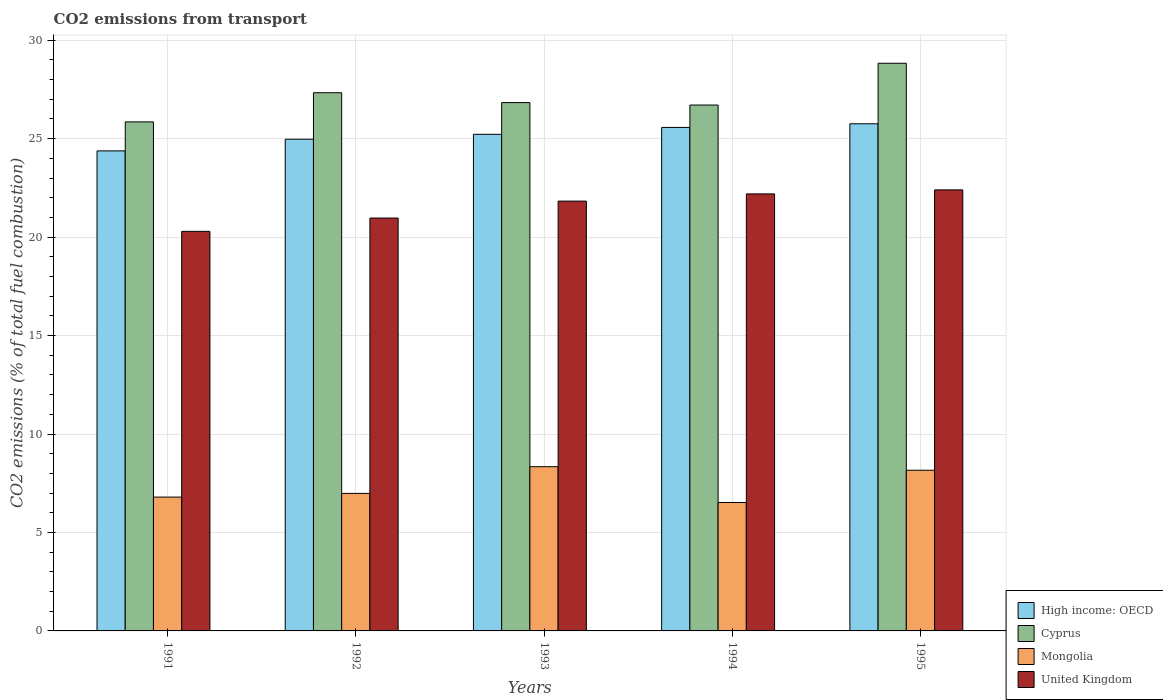How many different coloured bars are there?
Make the answer very short. 4. Are the number of bars per tick equal to the number of legend labels?
Give a very brief answer. Yes. Are the number of bars on each tick of the X-axis equal?
Provide a succinct answer. Yes. How many bars are there on the 4th tick from the right?
Make the answer very short. 4. What is the label of the 3rd group of bars from the left?
Ensure brevity in your answer.  1993. What is the total CO2 emitted in Mongolia in 1991?
Your answer should be compact. 6.8. Across all years, what is the maximum total CO2 emitted in Cyprus?
Offer a very short reply. 28.83. Across all years, what is the minimum total CO2 emitted in High income: OECD?
Ensure brevity in your answer.  24.38. In which year was the total CO2 emitted in High income: OECD minimum?
Your answer should be compact. 1991. What is the total total CO2 emitted in High income: OECD in the graph?
Your answer should be compact. 125.89. What is the difference between the total CO2 emitted in United Kingdom in 1991 and that in 1994?
Provide a short and direct response. -1.9. What is the difference between the total CO2 emitted in Cyprus in 1991 and the total CO2 emitted in Mongolia in 1995?
Offer a very short reply. 17.69. What is the average total CO2 emitted in United Kingdom per year?
Offer a very short reply. 21.53. In the year 1995, what is the difference between the total CO2 emitted in Cyprus and total CO2 emitted in United Kingdom?
Provide a short and direct response. 6.43. What is the ratio of the total CO2 emitted in Mongolia in 1993 to that in 1994?
Give a very brief answer. 1.28. Is the total CO2 emitted in Mongolia in 1991 less than that in 1993?
Give a very brief answer. Yes. Is the difference between the total CO2 emitted in Cyprus in 1991 and 1992 greater than the difference between the total CO2 emitted in United Kingdom in 1991 and 1992?
Offer a terse response. No. What is the difference between the highest and the second highest total CO2 emitted in Mongolia?
Offer a very short reply. 0.18. What is the difference between the highest and the lowest total CO2 emitted in Mongolia?
Offer a very short reply. 1.82. In how many years, is the total CO2 emitted in Cyprus greater than the average total CO2 emitted in Cyprus taken over all years?
Keep it short and to the point. 2. Is the sum of the total CO2 emitted in Mongolia in 1993 and 1995 greater than the maximum total CO2 emitted in High income: OECD across all years?
Offer a very short reply. No. What does the 3rd bar from the left in 1995 represents?
Give a very brief answer. Mongolia. What does the 2nd bar from the right in 1991 represents?
Offer a very short reply. Mongolia. Is it the case that in every year, the sum of the total CO2 emitted in United Kingdom and total CO2 emitted in High income: OECD is greater than the total CO2 emitted in Mongolia?
Offer a terse response. Yes. Does the graph contain any zero values?
Provide a short and direct response. No. How many legend labels are there?
Give a very brief answer. 4. What is the title of the graph?
Ensure brevity in your answer.  CO2 emissions from transport. What is the label or title of the Y-axis?
Provide a short and direct response. CO2 emissions (% of total fuel combustion). What is the CO2 emissions (% of total fuel combustion) in High income: OECD in 1991?
Offer a terse response. 24.38. What is the CO2 emissions (% of total fuel combustion) in Cyprus in 1991?
Your answer should be very brief. 25.85. What is the CO2 emissions (% of total fuel combustion) of Mongolia in 1991?
Your answer should be very brief. 6.8. What is the CO2 emissions (% of total fuel combustion) of United Kingdom in 1991?
Keep it short and to the point. 20.29. What is the CO2 emissions (% of total fuel combustion) in High income: OECD in 1992?
Give a very brief answer. 24.97. What is the CO2 emissions (% of total fuel combustion) of Cyprus in 1992?
Ensure brevity in your answer.  27.33. What is the CO2 emissions (% of total fuel combustion) of Mongolia in 1992?
Your answer should be very brief. 6.98. What is the CO2 emissions (% of total fuel combustion) in United Kingdom in 1992?
Keep it short and to the point. 20.97. What is the CO2 emissions (% of total fuel combustion) in High income: OECD in 1993?
Offer a terse response. 25.22. What is the CO2 emissions (% of total fuel combustion) of Cyprus in 1993?
Your answer should be compact. 26.83. What is the CO2 emissions (% of total fuel combustion) of Mongolia in 1993?
Provide a short and direct response. 8.34. What is the CO2 emissions (% of total fuel combustion) in United Kingdom in 1993?
Offer a terse response. 21.83. What is the CO2 emissions (% of total fuel combustion) of High income: OECD in 1994?
Make the answer very short. 25.57. What is the CO2 emissions (% of total fuel combustion) in Cyprus in 1994?
Provide a succinct answer. 26.71. What is the CO2 emissions (% of total fuel combustion) in Mongolia in 1994?
Give a very brief answer. 6.52. What is the CO2 emissions (% of total fuel combustion) in United Kingdom in 1994?
Give a very brief answer. 22.19. What is the CO2 emissions (% of total fuel combustion) in High income: OECD in 1995?
Keep it short and to the point. 25.75. What is the CO2 emissions (% of total fuel combustion) in Cyprus in 1995?
Your response must be concise. 28.83. What is the CO2 emissions (% of total fuel combustion) of Mongolia in 1995?
Keep it short and to the point. 8.16. What is the CO2 emissions (% of total fuel combustion) of United Kingdom in 1995?
Your response must be concise. 22.4. Across all years, what is the maximum CO2 emissions (% of total fuel combustion) of High income: OECD?
Offer a terse response. 25.75. Across all years, what is the maximum CO2 emissions (% of total fuel combustion) in Cyprus?
Your answer should be compact. 28.83. Across all years, what is the maximum CO2 emissions (% of total fuel combustion) in Mongolia?
Keep it short and to the point. 8.34. Across all years, what is the maximum CO2 emissions (% of total fuel combustion) of United Kingdom?
Keep it short and to the point. 22.4. Across all years, what is the minimum CO2 emissions (% of total fuel combustion) of High income: OECD?
Keep it short and to the point. 24.38. Across all years, what is the minimum CO2 emissions (% of total fuel combustion) in Cyprus?
Your response must be concise. 25.85. Across all years, what is the minimum CO2 emissions (% of total fuel combustion) in Mongolia?
Provide a succinct answer. 6.52. Across all years, what is the minimum CO2 emissions (% of total fuel combustion) of United Kingdom?
Your answer should be very brief. 20.29. What is the total CO2 emissions (% of total fuel combustion) of High income: OECD in the graph?
Make the answer very short. 125.89. What is the total CO2 emissions (% of total fuel combustion) of Cyprus in the graph?
Give a very brief answer. 135.54. What is the total CO2 emissions (% of total fuel combustion) in Mongolia in the graph?
Make the answer very short. 36.8. What is the total CO2 emissions (% of total fuel combustion) in United Kingdom in the graph?
Your answer should be very brief. 107.67. What is the difference between the CO2 emissions (% of total fuel combustion) in High income: OECD in 1991 and that in 1992?
Your answer should be compact. -0.59. What is the difference between the CO2 emissions (% of total fuel combustion) in Cyprus in 1991 and that in 1992?
Offer a terse response. -1.48. What is the difference between the CO2 emissions (% of total fuel combustion) of Mongolia in 1991 and that in 1992?
Offer a very short reply. -0.19. What is the difference between the CO2 emissions (% of total fuel combustion) in United Kingdom in 1991 and that in 1992?
Keep it short and to the point. -0.68. What is the difference between the CO2 emissions (% of total fuel combustion) in High income: OECD in 1991 and that in 1993?
Give a very brief answer. -0.84. What is the difference between the CO2 emissions (% of total fuel combustion) in Cyprus in 1991 and that in 1993?
Provide a short and direct response. -0.98. What is the difference between the CO2 emissions (% of total fuel combustion) in Mongolia in 1991 and that in 1993?
Give a very brief answer. -1.54. What is the difference between the CO2 emissions (% of total fuel combustion) in United Kingdom in 1991 and that in 1993?
Provide a succinct answer. -1.54. What is the difference between the CO2 emissions (% of total fuel combustion) in High income: OECD in 1991 and that in 1994?
Provide a succinct answer. -1.19. What is the difference between the CO2 emissions (% of total fuel combustion) in Cyprus in 1991 and that in 1994?
Keep it short and to the point. -0.86. What is the difference between the CO2 emissions (% of total fuel combustion) in Mongolia in 1991 and that in 1994?
Ensure brevity in your answer.  0.27. What is the difference between the CO2 emissions (% of total fuel combustion) of United Kingdom in 1991 and that in 1994?
Make the answer very short. -1.9. What is the difference between the CO2 emissions (% of total fuel combustion) of High income: OECD in 1991 and that in 1995?
Your answer should be very brief. -1.38. What is the difference between the CO2 emissions (% of total fuel combustion) of Cyprus in 1991 and that in 1995?
Keep it short and to the point. -2.98. What is the difference between the CO2 emissions (% of total fuel combustion) of Mongolia in 1991 and that in 1995?
Your answer should be very brief. -1.36. What is the difference between the CO2 emissions (% of total fuel combustion) of United Kingdom in 1991 and that in 1995?
Your response must be concise. -2.11. What is the difference between the CO2 emissions (% of total fuel combustion) of High income: OECD in 1992 and that in 1993?
Provide a succinct answer. -0.25. What is the difference between the CO2 emissions (% of total fuel combustion) in Cyprus in 1992 and that in 1993?
Make the answer very short. 0.5. What is the difference between the CO2 emissions (% of total fuel combustion) of Mongolia in 1992 and that in 1993?
Your response must be concise. -1.36. What is the difference between the CO2 emissions (% of total fuel combustion) of United Kingdom in 1992 and that in 1993?
Provide a short and direct response. -0.86. What is the difference between the CO2 emissions (% of total fuel combustion) of High income: OECD in 1992 and that in 1994?
Your answer should be compact. -0.6. What is the difference between the CO2 emissions (% of total fuel combustion) of Cyprus in 1992 and that in 1994?
Give a very brief answer. 0.62. What is the difference between the CO2 emissions (% of total fuel combustion) in Mongolia in 1992 and that in 1994?
Provide a succinct answer. 0.46. What is the difference between the CO2 emissions (% of total fuel combustion) of United Kingdom in 1992 and that in 1994?
Ensure brevity in your answer.  -1.23. What is the difference between the CO2 emissions (% of total fuel combustion) of High income: OECD in 1992 and that in 1995?
Your response must be concise. -0.78. What is the difference between the CO2 emissions (% of total fuel combustion) of Cyprus in 1992 and that in 1995?
Your answer should be very brief. -1.5. What is the difference between the CO2 emissions (% of total fuel combustion) in Mongolia in 1992 and that in 1995?
Your answer should be very brief. -1.18. What is the difference between the CO2 emissions (% of total fuel combustion) of United Kingdom in 1992 and that in 1995?
Ensure brevity in your answer.  -1.43. What is the difference between the CO2 emissions (% of total fuel combustion) in High income: OECD in 1993 and that in 1994?
Provide a short and direct response. -0.35. What is the difference between the CO2 emissions (% of total fuel combustion) of Cyprus in 1993 and that in 1994?
Offer a very short reply. 0.12. What is the difference between the CO2 emissions (% of total fuel combustion) in Mongolia in 1993 and that in 1994?
Your response must be concise. 1.82. What is the difference between the CO2 emissions (% of total fuel combustion) of United Kingdom in 1993 and that in 1994?
Your answer should be very brief. -0.37. What is the difference between the CO2 emissions (% of total fuel combustion) in High income: OECD in 1993 and that in 1995?
Make the answer very short. -0.53. What is the difference between the CO2 emissions (% of total fuel combustion) in Cyprus in 1993 and that in 1995?
Ensure brevity in your answer.  -2. What is the difference between the CO2 emissions (% of total fuel combustion) in Mongolia in 1993 and that in 1995?
Ensure brevity in your answer.  0.18. What is the difference between the CO2 emissions (% of total fuel combustion) in United Kingdom in 1993 and that in 1995?
Make the answer very short. -0.57. What is the difference between the CO2 emissions (% of total fuel combustion) of High income: OECD in 1994 and that in 1995?
Give a very brief answer. -0.18. What is the difference between the CO2 emissions (% of total fuel combustion) in Cyprus in 1994 and that in 1995?
Offer a very short reply. -2.12. What is the difference between the CO2 emissions (% of total fuel combustion) in Mongolia in 1994 and that in 1995?
Provide a short and direct response. -1.64. What is the difference between the CO2 emissions (% of total fuel combustion) in United Kingdom in 1994 and that in 1995?
Your response must be concise. -0.2. What is the difference between the CO2 emissions (% of total fuel combustion) in High income: OECD in 1991 and the CO2 emissions (% of total fuel combustion) in Cyprus in 1992?
Provide a succinct answer. -2.95. What is the difference between the CO2 emissions (% of total fuel combustion) in High income: OECD in 1991 and the CO2 emissions (% of total fuel combustion) in Mongolia in 1992?
Make the answer very short. 17.39. What is the difference between the CO2 emissions (% of total fuel combustion) in High income: OECD in 1991 and the CO2 emissions (% of total fuel combustion) in United Kingdom in 1992?
Make the answer very short. 3.41. What is the difference between the CO2 emissions (% of total fuel combustion) of Cyprus in 1991 and the CO2 emissions (% of total fuel combustion) of Mongolia in 1992?
Provide a succinct answer. 18.87. What is the difference between the CO2 emissions (% of total fuel combustion) in Cyprus in 1991 and the CO2 emissions (% of total fuel combustion) in United Kingdom in 1992?
Keep it short and to the point. 4.88. What is the difference between the CO2 emissions (% of total fuel combustion) of Mongolia in 1991 and the CO2 emissions (% of total fuel combustion) of United Kingdom in 1992?
Provide a succinct answer. -14.17. What is the difference between the CO2 emissions (% of total fuel combustion) in High income: OECD in 1991 and the CO2 emissions (% of total fuel combustion) in Cyprus in 1993?
Provide a short and direct response. -2.45. What is the difference between the CO2 emissions (% of total fuel combustion) of High income: OECD in 1991 and the CO2 emissions (% of total fuel combustion) of Mongolia in 1993?
Make the answer very short. 16.04. What is the difference between the CO2 emissions (% of total fuel combustion) in High income: OECD in 1991 and the CO2 emissions (% of total fuel combustion) in United Kingdom in 1993?
Ensure brevity in your answer.  2.55. What is the difference between the CO2 emissions (% of total fuel combustion) of Cyprus in 1991 and the CO2 emissions (% of total fuel combustion) of Mongolia in 1993?
Your answer should be very brief. 17.51. What is the difference between the CO2 emissions (% of total fuel combustion) in Cyprus in 1991 and the CO2 emissions (% of total fuel combustion) in United Kingdom in 1993?
Provide a short and direct response. 4.02. What is the difference between the CO2 emissions (% of total fuel combustion) of Mongolia in 1991 and the CO2 emissions (% of total fuel combustion) of United Kingdom in 1993?
Your answer should be very brief. -15.03. What is the difference between the CO2 emissions (% of total fuel combustion) of High income: OECD in 1991 and the CO2 emissions (% of total fuel combustion) of Cyprus in 1994?
Provide a short and direct response. -2.33. What is the difference between the CO2 emissions (% of total fuel combustion) in High income: OECD in 1991 and the CO2 emissions (% of total fuel combustion) in Mongolia in 1994?
Offer a very short reply. 17.86. What is the difference between the CO2 emissions (% of total fuel combustion) of High income: OECD in 1991 and the CO2 emissions (% of total fuel combustion) of United Kingdom in 1994?
Provide a succinct answer. 2.18. What is the difference between the CO2 emissions (% of total fuel combustion) of Cyprus in 1991 and the CO2 emissions (% of total fuel combustion) of Mongolia in 1994?
Your answer should be very brief. 19.33. What is the difference between the CO2 emissions (% of total fuel combustion) in Cyprus in 1991 and the CO2 emissions (% of total fuel combustion) in United Kingdom in 1994?
Ensure brevity in your answer.  3.66. What is the difference between the CO2 emissions (% of total fuel combustion) in Mongolia in 1991 and the CO2 emissions (% of total fuel combustion) in United Kingdom in 1994?
Make the answer very short. -15.4. What is the difference between the CO2 emissions (% of total fuel combustion) in High income: OECD in 1991 and the CO2 emissions (% of total fuel combustion) in Cyprus in 1995?
Offer a very short reply. -4.45. What is the difference between the CO2 emissions (% of total fuel combustion) of High income: OECD in 1991 and the CO2 emissions (% of total fuel combustion) of Mongolia in 1995?
Your answer should be very brief. 16.22. What is the difference between the CO2 emissions (% of total fuel combustion) of High income: OECD in 1991 and the CO2 emissions (% of total fuel combustion) of United Kingdom in 1995?
Your response must be concise. 1.98. What is the difference between the CO2 emissions (% of total fuel combustion) of Cyprus in 1991 and the CO2 emissions (% of total fuel combustion) of Mongolia in 1995?
Provide a succinct answer. 17.69. What is the difference between the CO2 emissions (% of total fuel combustion) in Cyprus in 1991 and the CO2 emissions (% of total fuel combustion) in United Kingdom in 1995?
Make the answer very short. 3.45. What is the difference between the CO2 emissions (% of total fuel combustion) of Mongolia in 1991 and the CO2 emissions (% of total fuel combustion) of United Kingdom in 1995?
Provide a succinct answer. -15.6. What is the difference between the CO2 emissions (% of total fuel combustion) of High income: OECD in 1992 and the CO2 emissions (% of total fuel combustion) of Cyprus in 1993?
Provide a short and direct response. -1.86. What is the difference between the CO2 emissions (% of total fuel combustion) in High income: OECD in 1992 and the CO2 emissions (% of total fuel combustion) in Mongolia in 1993?
Provide a succinct answer. 16.63. What is the difference between the CO2 emissions (% of total fuel combustion) of High income: OECD in 1992 and the CO2 emissions (% of total fuel combustion) of United Kingdom in 1993?
Your answer should be very brief. 3.14. What is the difference between the CO2 emissions (% of total fuel combustion) in Cyprus in 1992 and the CO2 emissions (% of total fuel combustion) in Mongolia in 1993?
Make the answer very short. 18.99. What is the difference between the CO2 emissions (% of total fuel combustion) of Cyprus in 1992 and the CO2 emissions (% of total fuel combustion) of United Kingdom in 1993?
Your answer should be compact. 5.5. What is the difference between the CO2 emissions (% of total fuel combustion) of Mongolia in 1992 and the CO2 emissions (% of total fuel combustion) of United Kingdom in 1993?
Your answer should be compact. -14.84. What is the difference between the CO2 emissions (% of total fuel combustion) of High income: OECD in 1992 and the CO2 emissions (% of total fuel combustion) of Cyprus in 1994?
Keep it short and to the point. -1.74. What is the difference between the CO2 emissions (% of total fuel combustion) of High income: OECD in 1992 and the CO2 emissions (% of total fuel combustion) of Mongolia in 1994?
Ensure brevity in your answer.  18.45. What is the difference between the CO2 emissions (% of total fuel combustion) in High income: OECD in 1992 and the CO2 emissions (% of total fuel combustion) in United Kingdom in 1994?
Give a very brief answer. 2.78. What is the difference between the CO2 emissions (% of total fuel combustion) of Cyprus in 1992 and the CO2 emissions (% of total fuel combustion) of Mongolia in 1994?
Ensure brevity in your answer.  20.81. What is the difference between the CO2 emissions (% of total fuel combustion) of Cyprus in 1992 and the CO2 emissions (% of total fuel combustion) of United Kingdom in 1994?
Offer a terse response. 5.14. What is the difference between the CO2 emissions (% of total fuel combustion) in Mongolia in 1992 and the CO2 emissions (% of total fuel combustion) in United Kingdom in 1994?
Your answer should be very brief. -15.21. What is the difference between the CO2 emissions (% of total fuel combustion) in High income: OECD in 1992 and the CO2 emissions (% of total fuel combustion) in Cyprus in 1995?
Offer a very short reply. -3.86. What is the difference between the CO2 emissions (% of total fuel combustion) of High income: OECD in 1992 and the CO2 emissions (% of total fuel combustion) of Mongolia in 1995?
Give a very brief answer. 16.81. What is the difference between the CO2 emissions (% of total fuel combustion) in High income: OECD in 1992 and the CO2 emissions (% of total fuel combustion) in United Kingdom in 1995?
Provide a succinct answer. 2.57. What is the difference between the CO2 emissions (% of total fuel combustion) of Cyprus in 1992 and the CO2 emissions (% of total fuel combustion) of Mongolia in 1995?
Make the answer very short. 19.17. What is the difference between the CO2 emissions (% of total fuel combustion) in Cyprus in 1992 and the CO2 emissions (% of total fuel combustion) in United Kingdom in 1995?
Provide a short and direct response. 4.93. What is the difference between the CO2 emissions (% of total fuel combustion) in Mongolia in 1992 and the CO2 emissions (% of total fuel combustion) in United Kingdom in 1995?
Offer a terse response. -15.41. What is the difference between the CO2 emissions (% of total fuel combustion) of High income: OECD in 1993 and the CO2 emissions (% of total fuel combustion) of Cyprus in 1994?
Provide a succinct answer. -1.49. What is the difference between the CO2 emissions (% of total fuel combustion) in High income: OECD in 1993 and the CO2 emissions (% of total fuel combustion) in Mongolia in 1994?
Provide a succinct answer. 18.7. What is the difference between the CO2 emissions (% of total fuel combustion) in High income: OECD in 1993 and the CO2 emissions (% of total fuel combustion) in United Kingdom in 1994?
Your answer should be very brief. 3.03. What is the difference between the CO2 emissions (% of total fuel combustion) of Cyprus in 1993 and the CO2 emissions (% of total fuel combustion) of Mongolia in 1994?
Provide a succinct answer. 20.31. What is the difference between the CO2 emissions (% of total fuel combustion) of Cyprus in 1993 and the CO2 emissions (% of total fuel combustion) of United Kingdom in 1994?
Provide a succinct answer. 4.64. What is the difference between the CO2 emissions (% of total fuel combustion) of Mongolia in 1993 and the CO2 emissions (% of total fuel combustion) of United Kingdom in 1994?
Provide a short and direct response. -13.85. What is the difference between the CO2 emissions (% of total fuel combustion) in High income: OECD in 1993 and the CO2 emissions (% of total fuel combustion) in Cyprus in 1995?
Make the answer very short. -3.61. What is the difference between the CO2 emissions (% of total fuel combustion) of High income: OECD in 1993 and the CO2 emissions (% of total fuel combustion) of Mongolia in 1995?
Your answer should be compact. 17.06. What is the difference between the CO2 emissions (% of total fuel combustion) of High income: OECD in 1993 and the CO2 emissions (% of total fuel combustion) of United Kingdom in 1995?
Your answer should be very brief. 2.82. What is the difference between the CO2 emissions (% of total fuel combustion) of Cyprus in 1993 and the CO2 emissions (% of total fuel combustion) of Mongolia in 1995?
Make the answer very short. 18.67. What is the difference between the CO2 emissions (% of total fuel combustion) of Cyprus in 1993 and the CO2 emissions (% of total fuel combustion) of United Kingdom in 1995?
Ensure brevity in your answer.  4.43. What is the difference between the CO2 emissions (% of total fuel combustion) of Mongolia in 1993 and the CO2 emissions (% of total fuel combustion) of United Kingdom in 1995?
Offer a very short reply. -14.06. What is the difference between the CO2 emissions (% of total fuel combustion) in High income: OECD in 1994 and the CO2 emissions (% of total fuel combustion) in Cyprus in 1995?
Your response must be concise. -3.26. What is the difference between the CO2 emissions (% of total fuel combustion) of High income: OECD in 1994 and the CO2 emissions (% of total fuel combustion) of Mongolia in 1995?
Provide a short and direct response. 17.41. What is the difference between the CO2 emissions (% of total fuel combustion) in High income: OECD in 1994 and the CO2 emissions (% of total fuel combustion) in United Kingdom in 1995?
Offer a terse response. 3.17. What is the difference between the CO2 emissions (% of total fuel combustion) in Cyprus in 1994 and the CO2 emissions (% of total fuel combustion) in Mongolia in 1995?
Your answer should be compact. 18.55. What is the difference between the CO2 emissions (% of total fuel combustion) of Cyprus in 1994 and the CO2 emissions (% of total fuel combustion) of United Kingdom in 1995?
Give a very brief answer. 4.31. What is the difference between the CO2 emissions (% of total fuel combustion) of Mongolia in 1994 and the CO2 emissions (% of total fuel combustion) of United Kingdom in 1995?
Your response must be concise. -15.87. What is the average CO2 emissions (% of total fuel combustion) of High income: OECD per year?
Provide a short and direct response. 25.18. What is the average CO2 emissions (% of total fuel combustion) in Cyprus per year?
Provide a short and direct response. 27.11. What is the average CO2 emissions (% of total fuel combustion) in Mongolia per year?
Your answer should be compact. 7.36. What is the average CO2 emissions (% of total fuel combustion) in United Kingdom per year?
Provide a short and direct response. 21.53. In the year 1991, what is the difference between the CO2 emissions (% of total fuel combustion) of High income: OECD and CO2 emissions (% of total fuel combustion) of Cyprus?
Ensure brevity in your answer.  -1.47. In the year 1991, what is the difference between the CO2 emissions (% of total fuel combustion) in High income: OECD and CO2 emissions (% of total fuel combustion) in Mongolia?
Offer a terse response. 17.58. In the year 1991, what is the difference between the CO2 emissions (% of total fuel combustion) of High income: OECD and CO2 emissions (% of total fuel combustion) of United Kingdom?
Ensure brevity in your answer.  4.09. In the year 1991, what is the difference between the CO2 emissions (% of total fuel combustion) of Cyprus and CO2 emissions (% of total fuel combustion) of Mongolia?
Give a very brief answer. 19.05. In the year 1991, what is the difference between the CO2 emissions (% of total fuel combustion) in Cyprus and CO2 emissions (% of total fuel combustion) in United Kingdom?
Make the answer very short. 5.56. In the year 1991, what is the difference between the CO2 emissions (% of total fuel combustion) in Mongolia and CO2 emissions (% of total fuel combustion) in United Kingdom?
Give a very brief answer. -13.49. In the year 1992, what is the difference between the CO2 emissions (% of total fuel combustion) of High income: OECD and CO2 emissions (% of total fuel combustion) of Cyprus?
Provide a succinct answer. -2.36. In the year 1992, what is the difference between the CO2 emissions (% of total fuel combustion) of High income: OECD and CO2 emissions (% of total fuel combustion) of Mongolia?
Make the answer very short. 17.99. In the year 1992, what is the difference between the CO2 emissions (% of total fuel combustion) in High income: OECD and CO2 emissions (% of total fuel combustion) in United Kingdom?
Give a very brief answer. 4. In the year 1992, what is the difference between the CO2 emissions (% of total fuel combustion) of Cyprus and CO2 emissions (% of total fuel combustion) of Mongolia?
Provide a succinct answer. 20.35. In the year 1992, what is the difference between the CO2 emissions (% of total fuel combustion) in Cyprus and CO2 emissions (% of total fuel combustion) in United Kingdom?
Make the answer very short. 6.36. In the year 1992, what is the difference between the CO2 emissions (% of total fuel combustion) of Mongolia and CO2 emissions (% of total fuel combustion) of United Kingdom?
Give a very brief answer. -13.98. In the year 1993, what is the difference between the CO2 emissions (% of total fuel combustion) in High income: OECD and CO2 emissions (% of total fuel combustion) in Cyprus?
Offer a terse response. -1.61. In the year 1993, what is the difference between the CO2 emissions (% of total fuel combustion) in High income: OECD and CO2 emissions (% of total fuel combustion) in Mongolia?
Provide a succinct answer. 16.88. In the year 1993, what is the difference between the CO2 emissions (% of total fuel combustion) in High income: OECD and CO2 emissions (% of total fuel combustion) in United Kingdom?
Provide a succinct answer. 3.39. In the year 1993, what is the difference between the CO2 emissions (% of total fuel combustion) in Cyprus and CO2 emissions (% of total fuel combustion) in Mongolia?
Provide a short and direct response. 18.49. In the year 1993, what is the difference between the CO2 emissions (% of total fuel combustion) of Cyprus and CO2 emissions (% of total fuel combustion) of United Kingdom?
Offer a very short reply. 5. In the year 1993, what is the difference between the CO2 emissions (% of total fuel combustion) of Mongolia and CO2 emissions (% of total fuel combustion) of United Kingdom?
Provide a short and direct response. -13.49. In the year 1994, what is the difference between the CO2 emissions (% of total fuel combustion) of High income: OECD and CO2 emissions (% of total fuel combustion) of Cyprus?
Keep it short and to the point. -1.14. In the year 1994, what is the difference between the CO2 emissions (% of total fuel combustion) in High income: OECD and CO2 emissions (% of total fuel combustion) in Mongolia?
Offer a very short reply. 19.05. In the year 1994, what is the difference between the CO2 emissions (% of total fuel combustion) of High income: OECD and CO2 emissions (% of total fuel combustion) of United Kingdom?
Offer a terse response. 3.38. In the year 1994, what is the difference between the CO2 emissions (% of total fuel combustion) in Cyprus and CO2 emissions (% of total fuel combustion) in Mongolia?
Your response must be concise. 20.18. In the year 1994, what is the difference between the CO2 emissions (% of total fuel combustion) of Cyprus and CO2 emissions (% of total fuel combustion) of United Kingdom?
Give a very brief answer. 4.51. In the year 1994, what is the difference between the CO2 emissions (% of total fuel combustion) of Mongolia and CO2 emissions (% of total fuel combustion) of United Kingdom?
Make the answer very short. -15.67. In the year 1995, what is the difference between the CO2 emissions (% of total fuel combustion) of High income: OECD and CO2 emissions (% of total fuel combustion) of Cyprus?
Keep it short and to the point. -3.07. In the year 1995, what is the difference between the CO2 emissions (% of total fuel combustion) in High income: OECD and CO2 emissions (% of total fuel combustion) in Mongolia?
Make the answer very short. 17.59. In the year 1995, what is the difference between the CO2 emissions (% of total fuel combustion) in High income: OECD and CO2 emissions (% of total fuel combustion) in United Kingdom?
Provide a succinct answer. 3.36. In the year 1995, what is the difference between the CO2 emissions (% of total fuel combustion) in Cyprus and CO2 emissions (% of total fuel combustion) in Mongolia?
Make the answer very short. 20.67. In the year 1995, what is the difference between the CO2 emissions (% of total fuel combustion) in Cyprus and CO2 emissions (% of total fuel combustion) in United Kingdom?
Make the answer very short. 6.43. In the year 1995, what is the difference between the CO2 emissions (% of total fuel combustion) of Mongolia and CO2 emissions (% of total fuel combustion) of United Kingdom?
Offer a terse response. -14.24. What is the ratio of the CO2 emissions (% of total fuel combustion) in High income: OECD in 1991 to that in 1992?
Provide a short and direct response. 0.98. What is the ratio of the CO2 emissions (% of total fuel combustion) of Cyprus in 1991 to that in 1992?
Your answer should be very brief. 0.95. What is the ratio of the CO2 emissions (% of total fuel combustion) of Mongolia in 1991 to that in 1992?
Provide a succinct answer. 0.97. What is the ratio of the CO2 emissions (% of total fuel combustion) of High income: OECD in 1991 to that in 1993?
Your answer should be very brief. 0.97. What is the ratio of the CO2 emissions (% of total fuel combustion) in Cyprus in 1991 to that in 1993?
Provide a succinct answer. 0.96. What is the ratio of the CO2 emissions (% of total fuel combustion) of Mongolia in 1991 to that in 1993?
Give a very brief answer. 0.81. What is the ratio of the CO2 emissions (% of total fuel combustion) of United Kingdom in 1991 to that in 1993?
Your answer should be compact. 0.93. What is the ratio of the CO2 emissions (% of total fuel combustion) of High income: OECD in 1991 to that in 1994?
Offer a terse response. 0.95. What is the ratio of the CO2 emissions (% of total fuel combustion) of Cyprus in 1991 to that in 1994?
Provide a succinct answer. 0.97. What is the ratio of the CO2 emissions (% of total fuel combustion) of Mongolia in 1991 to that in 1994?
Offer a terse response. 1.04. What is the ratio of the CO2 emissions (% of total fuel combustion) in United Kingdom in 1991 to that in 1994?
Provide a succinct answer. 0.91. What is the ratio of the CO2 emissions (% of total fuel combustion) of High income: OECD in 1991 to that in 1995?
Your answer should be compact. 0.95. What is the ratio of the CO2 emissions (% of total fuel combustion) in Cyprus in 1991 to that in 1995?
Ensure brevity in your answer.  0.9. What is the ratio of the CO2 emissions (% of total fuel combustion) of Mongolia in 1991 to that in 1995?
Give a very brief answer. 0.83. What is the ratio of the CO2 emissions (% of total fuel combustion) of United Kingdom in 1991 to that in 1995?
Make the answer very short. 0.91. What is the ratio of the CO2 emissions (% of total fuel combustion) in Cyprus in 1992 to that in 1993?
Give a very brief answer. 1.02. What is the ratio of the CO2 emissions (% of total fuel combustion) of Mongolia in 1992 to that in 1993?
Offer a terse response. 0.84. What is the ratio of the CO2 emissions (% of total fuel combustion) in United Kingdom in 1992 to that in 1993?
Offer a terse response. 0.96. What is the ratio of the CO2 emissions (% of total fuel combustion) in High income: OECD in 1992 to that in 1994?
Give a very brief answer. 0.98. What is the ratio of the CO2 emissions (% of total fuel combustion) of Cyprus in 1992 to that in 1994?
Give a very brief answer. 1.02. What is the ratio of the CO2 emissions (% of total fuel combustion) of Mongolia in 1992 to that in 1994?
Your answer should be very brief. 1.07. What is the ratio of the CO2 emissions (% of total fuel combustion) in United Kingdom in 1992 to that in 1994?
Provide a succinct answer. 0.94. What is the ratio of the CO2 emissions (% of total fuel combustion) in High income: OECD in 1992 to that in 1995?
Ensure brevity in your answer.  0.97. What is the ratio of the CO2 emissions (% of total fuel combustion) in Cyprus in 1992 to that in 1995?
Give a very brief answer. 0.95. What is the ratio of the CO2 emissions (% of total fuel combustion) in Mongolia in 1992 to that in 1995?
Your answer should be compact. 0.86. What is the ratio of the CO2 emissions (% of total fuel combustion) of United Kingdom in 1992 to that in 1995?
Make the answer very short. 0.94. What is the ratio of the CO2 emissions (% of total fuel combustion) of High income: OECD in 1993 to that in 1994?
Offer a terse response. 0.99. What is the ratio of the CO2 emissions (% of total fuel combustion) in Cyprus in 1993 to that in 1994?
Ensure brevity in your answer.  1. What is the ratio of the CO2 emissions (% of total fuel combustion) in Mongolia in 1993 to that in 1994?
Ensure brevity in your answer.  1.28. What is the ratio of the CO2 emissions (% of total fuel combustion) of United Kingdom in 1993 to that in 1994?
Provide a short and direct response. 0.98. What is the ratio of the CO2 emissions (% of total fuel combustion) of High income: OECD in 1993 to that in 1995?
Your answer should be very brief. 0.98. What is the ratio of the CO2 emissions (% of total fuel combustion) in Cyprus in 1993 to that in 1995?
Your answer should be very brief. 0.93. What is the ratio of the CO2 emissions (% of total fuel combustion) in Mongolia in 1993 to that in 1995?
Offer a very short reply. 1.02. What is the ratio of the CO2 emissions (% of total fuel combustion) in United Kingdom in 1993 to that in 1995?
Your answer should be very brief. 0.97. What is the ratio of the CO2 emissions (% of total fuel combustion) of High income: OECD in 1994 to that in 1995?
Provide a short and direct response. 0.99. What is the ratio of the CO2 emissions (% of total fuel combustion) of Cyprus in 1994 to that in 1995?
Ensure brevity in your answer.  0.93. What is the ratio of the CO2 emissions (% of total fuel combustion) in Mongolia in 1994 to that in 1995?
Give a very brief answer. 0.8. What is the ratio of the CO2 emissions (% of total fuel combustion) in United Kingdom in 1994 to that in 1995?
Your response must be concise. 0.99. What is the difference between the highest and the second highest CO2 emissions (% of total fuel combustion) in High income: OECD?
Offer a terse response. 0.18. What is the difference between the highest and the second highest CO2 emissions (% of total fuel combustion) of Cyprus?
Your answer should be very brief. 1.5. What is the difference between the highest and the second highest CO2 emissions (% of total fuel combustion) of Mongolia?
Your answer should be compact. 0.18. What is the difference between the highest and the second highest CO2 emissions (% of total fuel combustion) in United Kingdom?
Your answer should be very brief. 0.2. What is the difference between the highest and the lowest CO2 emissions (% of total fuel combustion) of High income: OECD?
Ensure brevity in your answer.  1.38. What is the difference between the highest and the lowest CO2 emissions (% of total fuel combustion) of Cyprus?
Offer a very short reply. 2.98. What is the difference between the highest and the lowest CO2 emissions (% of total fuel combustion) of Mongolia?
Ensure brevity in your answer.  1.82. What is the difference between the highest and the lowest CO2 emissions (% of total fuel combustion) of United Kingdom?
Give a very brief answer. 2.11. 